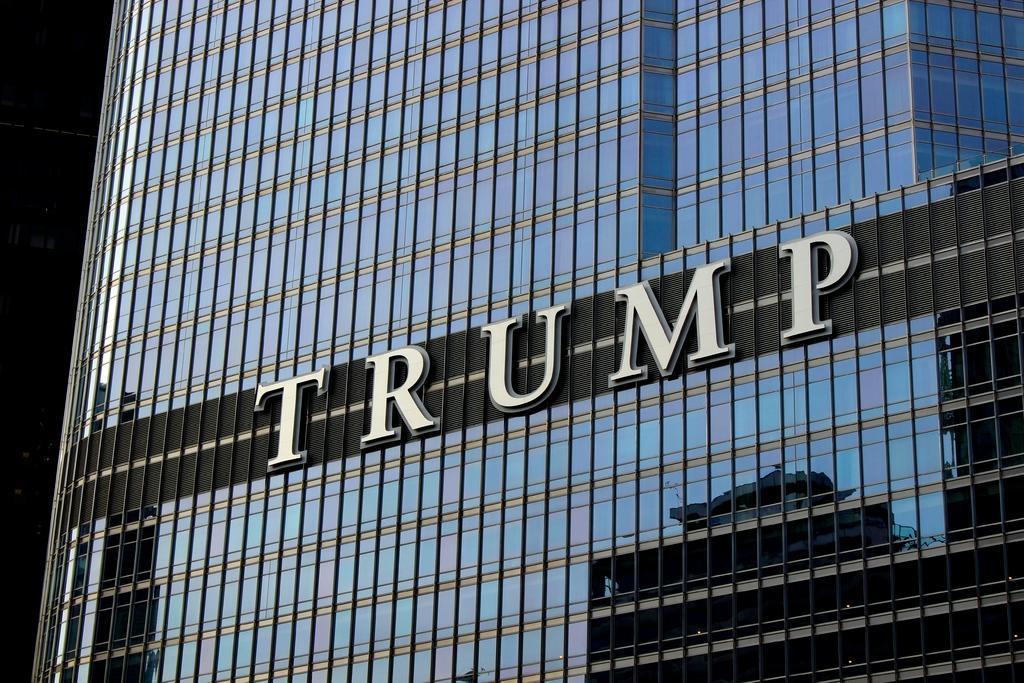In one or two sentences, can you explain what this image depicts? In this image we can see a building and there is a board. 